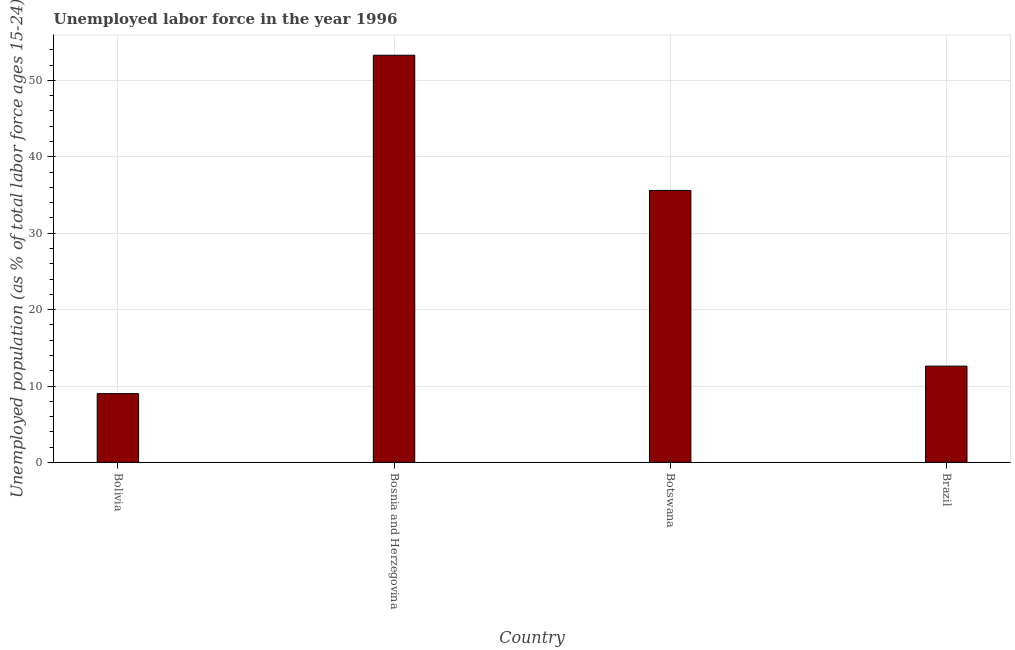Does the graph contain any zero values?
Your answer should be compact. No. What is the title of the graph?
Offer a terse response. Unemployed labor force in the year 1996. What is the label or title of the X-axis?
Your answer should be compact. Country. What is the label or title of the Y-axis?
Keep it short and to the point. Unemployed population (as % of total labor force ages 15-24). Across all countries, what is the maximum total unemployed youth population?
Make the answer very short. 53.3. In which country was the total unemployed youth population maximum?
Give a very brief answer. Bosnia and Herzegovina. What is the sum of the total unemployed youth population?
Make the answer very short. 110.5. What is the difference between the total unemployed youth population in Bolivia and Botswana?
Your answer should be compact. -26.6. What is the average total unemployed youth population per country?
Provide a short and direct response. 27.62. What is the median total unemployed youth population?
Offer a terse response. 24.1. In how many countries, is the total unemployed youth population greater than 24 %?
Keep it short and to the point. 2. What is the ratio of the total unemployed youth population in Bosnia and Herzegovina to that in Brazil?
Your response must be concise. 4.23. Is the difference between the total unemployed youth population in Bolivia and Brazil greater than the difference between any two countries?
Provide a short and direct response. No. What is the difference between the highest and the lowest total unemployed youth population?
Give a very brief answer. 44.3. How many bars are there?
Offer a very short reply. 4. Are all the bars in the graph horizontal?
Offer a very short reply. No. How many countries are there in the graph?
Provide a succinct answer. 4. Are the values on the major ticks of Y-axis written in scientific E-notation?
Keep it short and to the point. No. What is the Unemployed population (as % of total labor force ages 15-24) of Bolivia?
Provide a succinct answer. 9. What is the Unemployed population (as % of total labor force ages 15-24) of Bosnia and Herzegovina?
Offer a terse response. 53.3. What is the Unemployed population (as % of total labor force ages 15-24) of Botswana?
Give a very brief answer. 35.6. What is the Unemployed population (as % of total labor force ages 15-24) of Brazil?
Your answer should be very brief. 12.6. What is the difference between the Unemployed population (as % of total labor force ages 15-24) in Bolivia and Bosnia and Herzegovina?
Your answer should be very brief. -44.3. What is the difference between the Unemployed population (as % of total labor force ages 15-24) in Bolivia and Botswana?
Offer a very short reply. -26.6. What is the difference between the Unemployed population (as % of total labor force ages 15-24) in Bosnia and Herzegovina and Brazil?
Your answer should be very brief. 40.7. What is the ratio of the Unemployed population (as % of total labor force ages 15-24) in Bolivia to that in Bosnia and Herzegovina?
Make the answer very short. 0.17. What is the ratio of the Unemployed population (as % of total labor force ages 15-24) in Bolivia to that in Botswana?
Your answer should be very brief. 0.25. What is the ratio of the Unemployed population (as % of total labor force ages 15-24) in Bolivia to that in Brazil?
Provide a succinct answer. 0.71. What is the ratio of the Unemployed population (as % of total labor force ages 15-24) in Bosnia and Herzegovina to that in Botswana?
Make the answer very short. 1.5. What is the ratio of the Unemployed population (as % of total labor force ages 15-24) in Bosnia and Herzegovina to that in Brazil?
Your response must be concise. 4.23. What is the ratio of the Unemployed population (as % of total labor force ages 15-24) in Botswana to that in Brazil?
Provide a succinct answer. 2.83. 